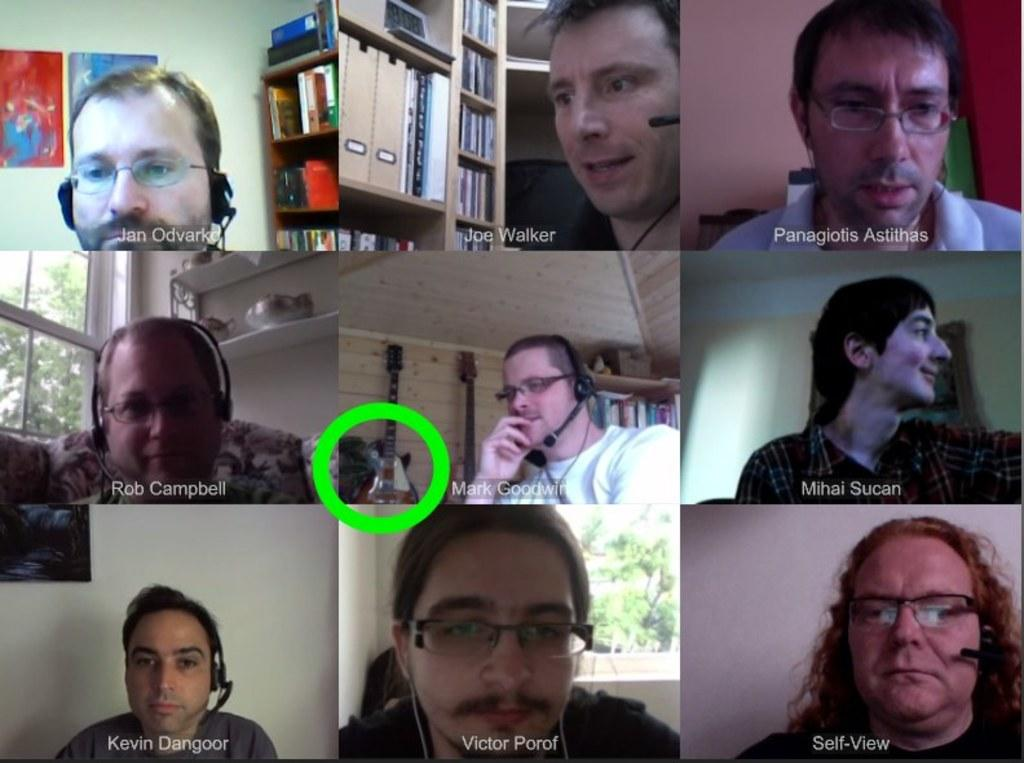What type of setting is depicted in the image? The image appears to be a conference video call. How many people are visible in the image? There are multiple people in the image. What are the people wearing that might be related to the video call? The people are wearing headsets. Can you see any cups of soap on the ocean in the image? There is no reference to cups, soap, or the ocean in the image; it is a conference video call with multiple people wearing headsets. 